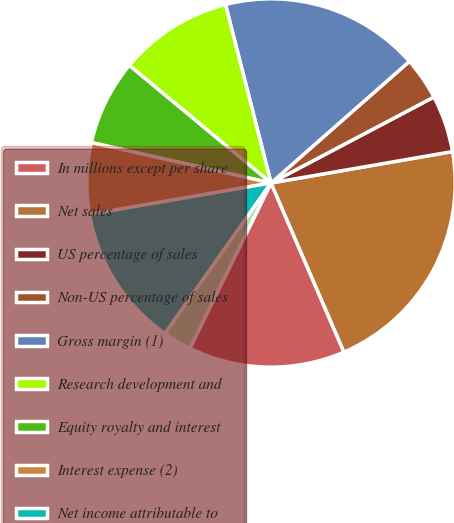Convert chart to OTSL. <chart><loc_0><loc_0><loc_500><loc_500><pie_chart><fcel>In millions except per share<fcel>Net sales<fcel>US percentage of sales<fcel>Non-US percentage of sales<fcel>Gross margin (1)<fcel>Research development and<fcel>Equity royalty and interest<fcel>Interest expense (2)<fcel>Net income attributable to<fcel>Basic<nl><fcel>13.75%<fcel>21.25%<fcel>5.0%<fcel>3.75%<fcel>17.5%<fcel>10.0%<fcel>7.5%<fcel>6.25%<fcel>12.5%<fcel>2.5%<nl></chart> 